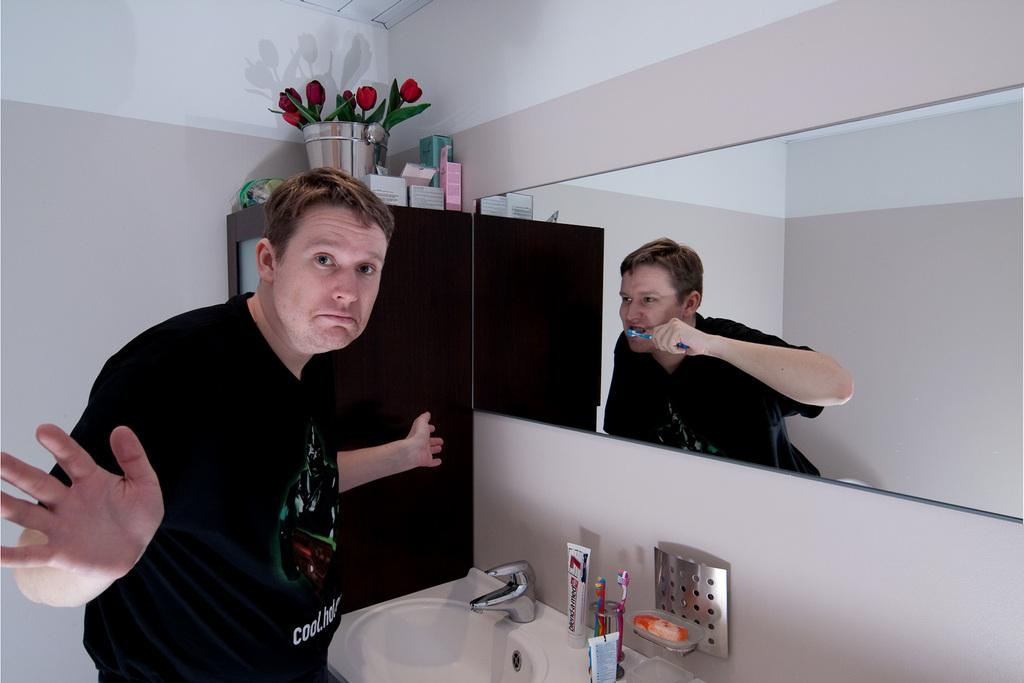<image>
Write a terse but informative summary of the picture. A man is brushing his teeth in the mirror but he is not and his shirt says Cool. 